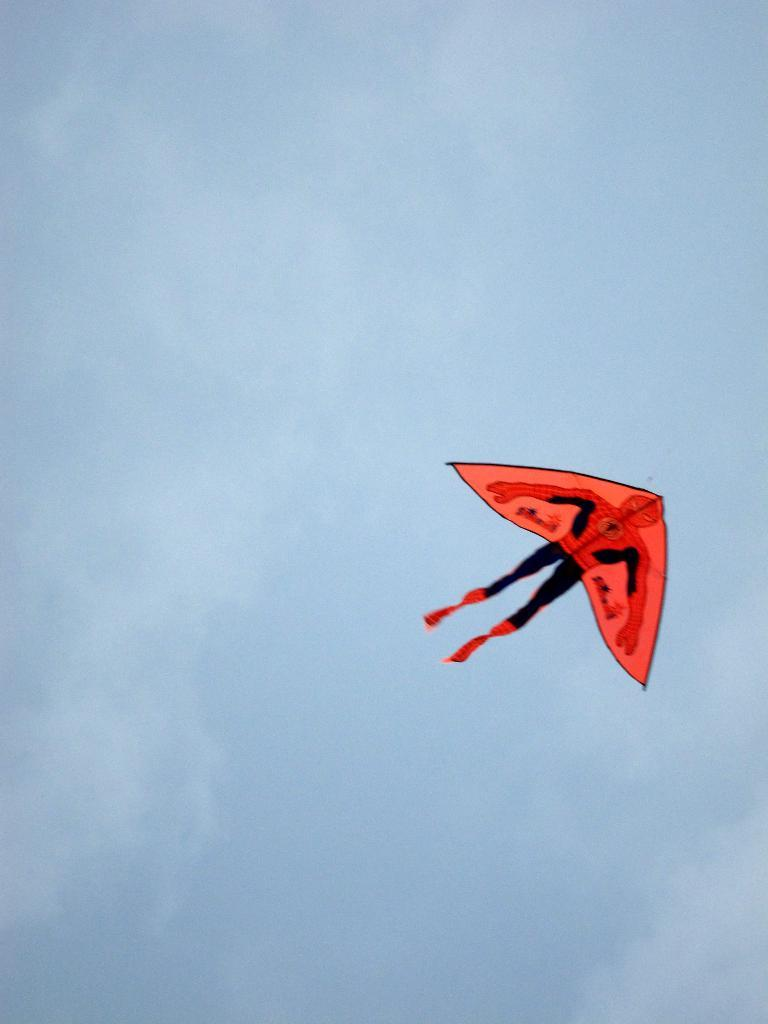What is flying in the sky in the image? There is a kite flying in the sky in the image. What else can be seen in the sky besides the kite? Clouds are visible in the sky. What type of field can be seen in the image? There is no field present in the image; it only features a kite flying in the sky and clouds. What does the image smell like? The image does not have a smell, as it is a visual representation. 